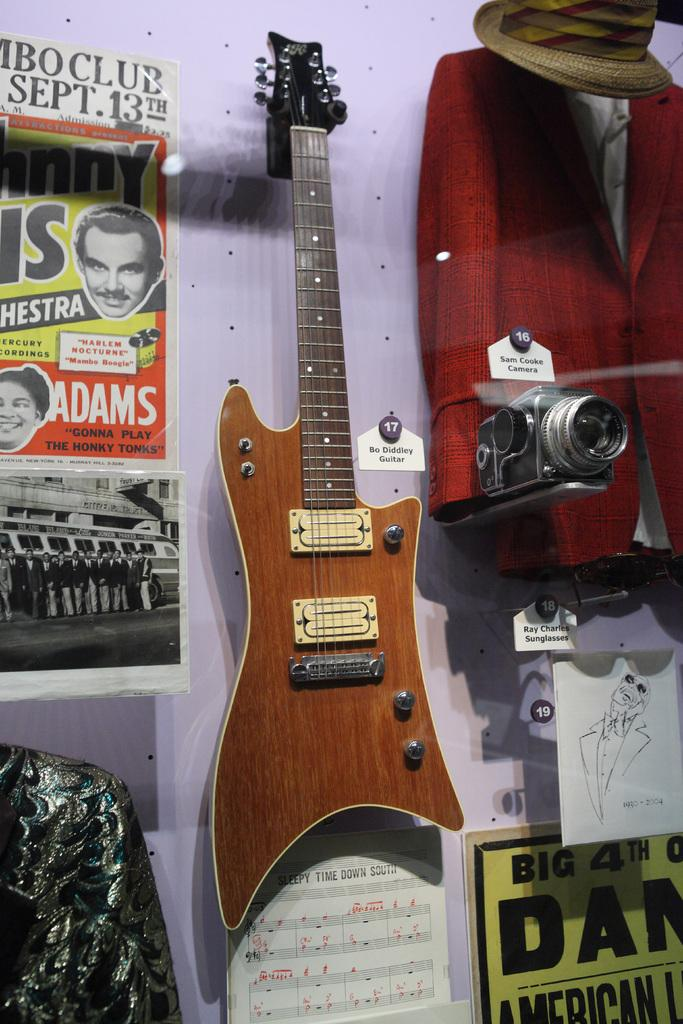What is attached to the wall in the image? There is a guitar hanger and a paper or banner pinned to the wall in the image. What is another object visible on the wall? There is a whiteboard in the image. Can you describe the instrument in the image? There is an instrument attached to a camera in the image. What type of plantation can be seen in the image? There is no plantation present in the image. How does the grass in the image show respect to the viewers? There is no grass present in the image, and therefore it cannot show respect to the viewers. 